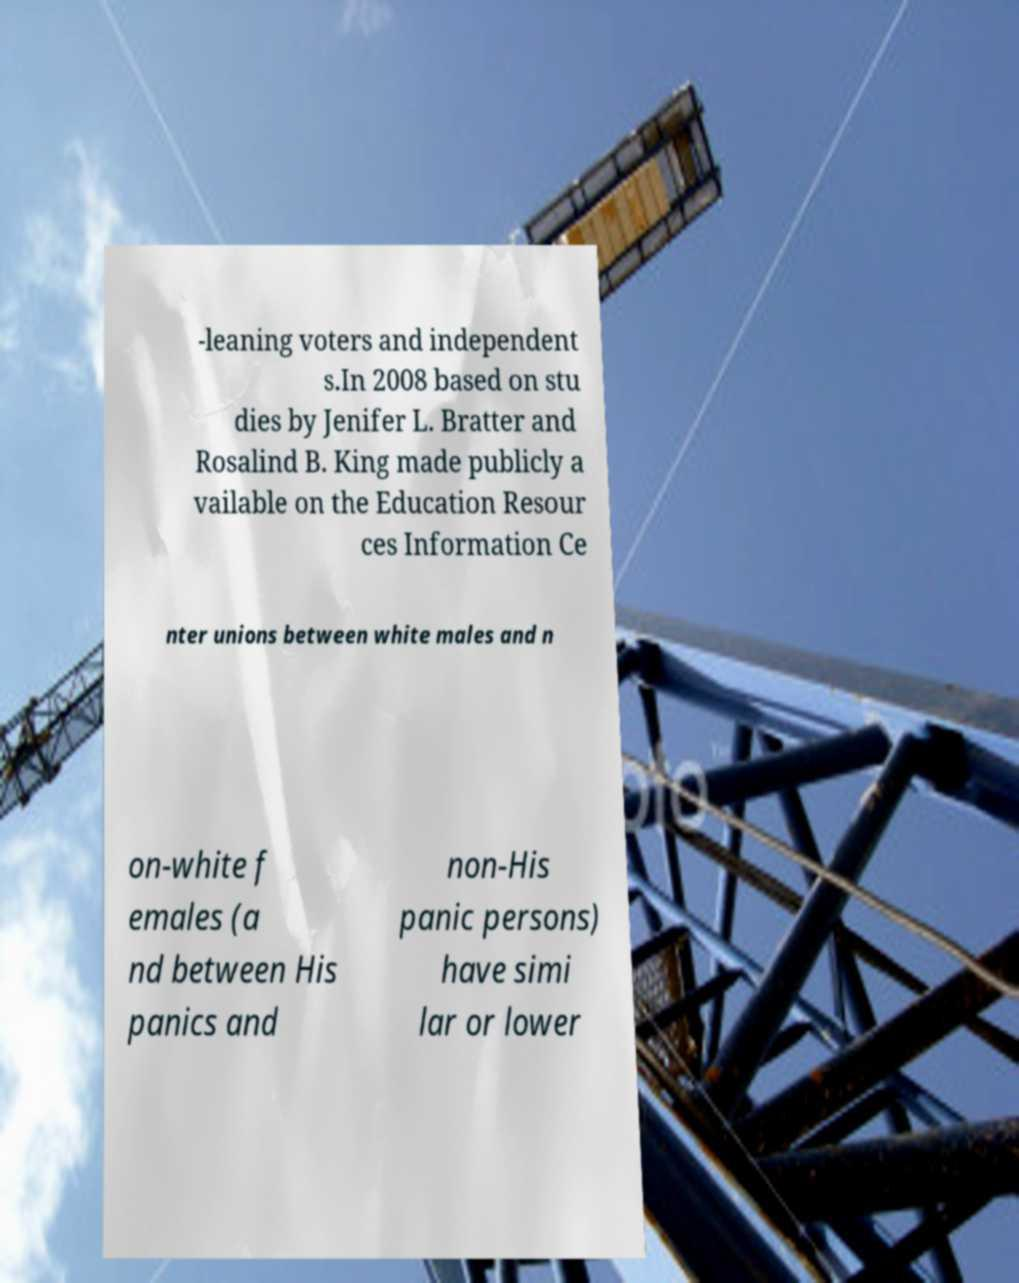Can you read and provide the text displayed in the image?This photo seems to have some interesting text. Can you extract and type it out for me? -leaning voters and independent s.In 2008 based on stu dies by Jenifer L. Bratter and Rosalind B. King made publicly a vailable on the Education Resour ces Information Ce nter unions between white males and n on-white f emales (a nd between His panics and non-His panic persons) have simi lar or lower 